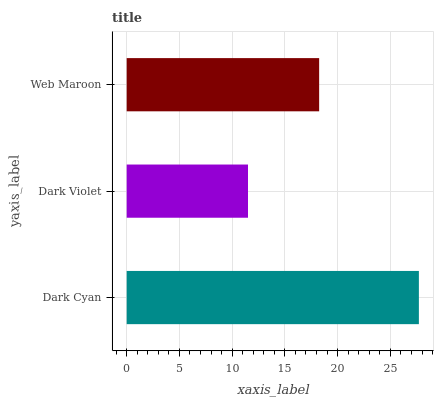Is Dark Violet the minimum?
Answer yes or no. Yes. Is Dark Cyan the maximum?
Answer yes or no. Yes. Is Web Maroon the minimum?
Answer yes or no. No. Is Web Maroon the maximum?
Answer yes or no. No. Is Web Maroon greater than Dark Violet?
Answer yes or no. Yes. Is Dark Violet less than Web Maroon?
Answer yes or no. Yes. Is Dark Violet greater than Web Maroon?
Answer yes or no. No. Is Web Maroon less than Dark Violet?
Answer yes or no. No. Is Web Maroon the high median?
Answer yes or no. Yes. Is Web Maroon the low median?
Answer yes or no. Yes. Is Dark Cyan the high median?
Answer yes or no. No. Is Dark Cyan the low median?
Answer yes or no. No. 